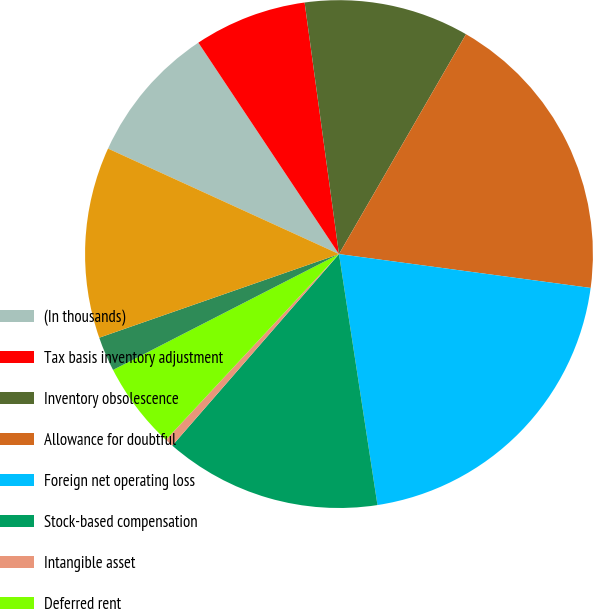<chart> <loc_0><loc_0><loc_500><loc_500><pie_chart><fcel>(In thousands)<fcel>Tax basis inventory adjustment<fcel>Inventory obsolescence<fcel>Allowance for doubtful<fcel>Foreign net operating loss<fcel>Stock-based compensation<fcel>Intangible asset<fcel>Deferred rent<fcel>Deferred compensation<fcel>Other<nl><fcel>8.84%<fcel>7.18%<fcel>10.5%<fcel>18.79%<fcel>20.45%<fcel>13.82%<fcel>0.54%<fcel>5.52%<fcel>2.2%<fcel>12.16%<nl></chart> 